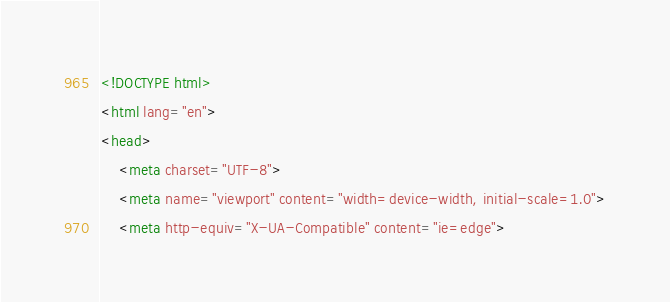Convert code to text. <code><loc_0><loc_0><loc_500><loc_500><_HTML_><!DOCTYPE html>
<html lang="en">
<head>
    <meta charset="UTF-8">
    <meta name="viewport" content="width=device-width, initial-scale=1.0">
    <meta http-equiv="X-UA-Compatible" content="ie=edge"></code> 